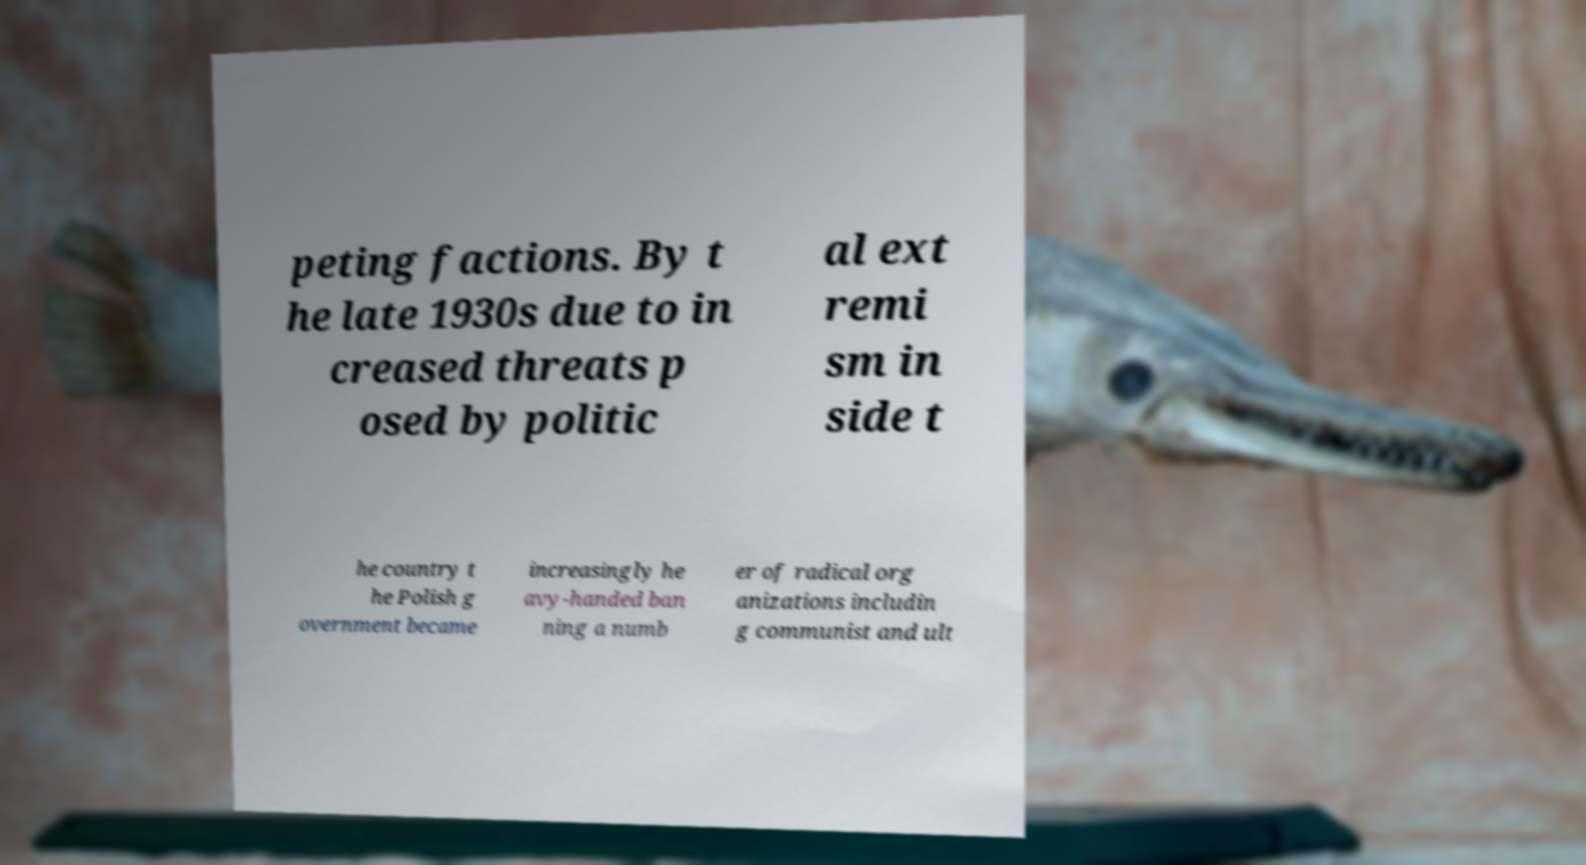For documentation purposes, I need the text within this image transcribed. Could you provide that? peting factions. By t he late 1930s due to in creased threats p osed by politic al ext remi sm in side t he country t he Polish g overnment became increasingly he avy-handed ban ning a numb er of radical org anizations includin g communist and ult 